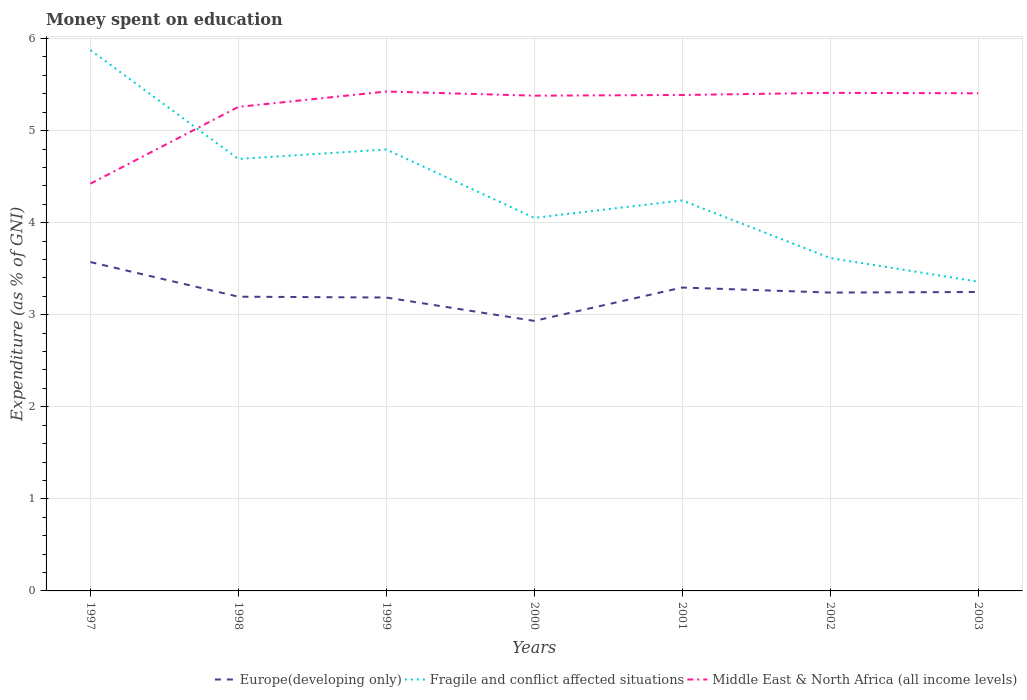Is the number of lines equal to the number of legend labels?
Give a very brief answer. Yes. Across all years, what is the maximum amount of money spent on education in Fragile and conflict affected situations?
Give a very brief answer. 3.36. What is the total amount of money spent on education in Middle East & North Africa (all income levels) in the graph?
Provide a short and direct response. -0.01. What is the difference between the highest and the second highest amount of money spent on education in Fragile and conflict affected situations?
Your answer should be compact. 2.52. How many years are there in the graph?
Provide a short and direct response. 7. Are the values on the major ticks of Y-axis written in scientific E-notation?
Make the answer very short. No. How many legend labels are there?
Ensure brevity in your answer.  3. What is the title of the graph?
Your answer should be very brief. Money spent on education. Does "Upper middle income" appear as one of the legend labels in the graph?
Make the answer very short. No. What is the label or title of the Y-axis?
Make the answer very short. Expenditure (as % of GNI). What is the Expenditure (as % of GNI) in Europe(developing only) in 1997?
Make the answer very short. 3.57. What is the Expenditure (as % of GNI) in Fragile and conflict affected situations in 1997?
Provide a succinct answer. 5.87. What is the Expenditure (as % of GNI) in Middle East & North Africa (all income levels) in 1997?
Give a very brief answer. 4.42. What is the Expenditure (as % of GNI) of Europe(developing only) in 1998?
Make the answer very short. 3.2. What is the Expenditure (as % of GNI) in Fragile and conflict affected situations in 1998?
Ensure brevity in your answer.  4.69. What is the Expenditure (as % of GNI) in Middle East & North Africa (all income levels) in 1998?
Make the answer very short. 5.26. What is the Expenditure (as % of GNI) in Europe(developing only) in 1999?
Your response must be concise. 3.19. What is the Expenditure (as % of GNI) in Fragile and conflict affected situations in 1999?
Your response must be concise. 4.79. What is the Expenditure (as % of GNI) of Middle East & North Africa (all income levels) in 1999?
Your response must be concise. 5.42. What is the Expenditure (as % of GNI) of Europe(developing only) in 2000?
Provide a succinct answer. 2.93. What is the Expenditure (as % of GNI) of Fragile and conflict affected situations in 2000?
Make the answer very short. 4.05. What is the Expenditure (as % of GNI) in Middle East & North Africa (all income levels) in 2000?
Your response must be concise. 5.38. What is the Expenditure (as % of GNI) of Europe(developing only) in 2001?
Offer a terse response. 3.3. What is the Expenditure (as % of GNI) of Fragile and conflict affected situations in 2001?
Provide a short and direct response. 4.24. What is the Expenditure (as % of GNI) of Middle East & North Africa (all income levels) in 2001?
Your answer should be very brief. 5.39. What is the Expenditure (as % of GNI) in Europe(developing only) in 2002?
Provide a short and direct response. 3.24. What is the Expenditure (as % of GNI) of Fragile and conflict affected situations in 2002?
Keep it short and to the point. 3.62. What is the Expenditure (as % of GNI) in Middle East & North Africa (all income levels) in 2002?
Your answer should be very brief. 5.41. What is the Expenditure (as % of GNI) of Europe(developing only) in 2003?
Your answer should be very brief. 3.25. What is the Expenditure (as % of GNI) in Fragile and conflict affected situations in 2003?
Offer a very short reply. 3.36. What is the Expenditure (as % of GNI) in Middle East & North Africa (all income levels) in 2003?
Make the answer very short. 5.41. Across all years, what is the maximum Expenditure (as % of GNI) in Europe(developing only)?
Provide a short and direct response. 3.57. Across all years, what is the maximum Expenditure (as % of GNI) in Fragile and conflict affected situations?
Make the answer very short. 5.87. Across all years, what is the maximum Expenditure (as % of GNI) in Middle East & North Africa (all income levels)?
Give a very brief answer. 5.42. Across all years, what is the minimum Expenditure (as % of GNI) of Europe(developing only)?
Provide a short and direct response. 2.93. Across all years, what is the minimum Expenditure (as % of GNI) in Fragile and conflict affected situations?
Provide a short and direct response. 3.36. Across all years, what is the minimum Expenditure (as % of GNI) in Middle East & North Africa (all income levels)?
Offer a terse response. 4.42. What is the total Expenditure (as % of GNI) of Europe(developing only) in the graph?
Your response must be concise. 22.67. What is the total Expenditure (as % of GNI) of Fragile and conflict affected situations in the graph?
Ensure brevity in your answer.  30.63. What is the total Expenditure (as % of GNI) in Middle East & North Africa (all income levels) in the graph?
Provide a succinct answer. 36.69. What is the difference between the Expenditure (as % of GNI) in Europe(developing only) in 1997 and that in 1998?
Provide a short and direct response. 0.38. What is the difference between the Expenditure (as % of GNI) of Fragile and conflict affected situations in 1997 and that in 1998?
Your answer should be compact. 1.18. What is the difference between the Expenditure (as % of GNI) of Middle East & North Africa (all income levels) in 1997 and that in 1998?
Give a very brief answer. -0.83. What is the difference between the Expenditure (as % of GNI) of Europe(developing only) in 1997 and that in 1999?
Give a very brief answer. 0.38. What is the difference between the Expenditure (as % of GNI) in Fragile and conflict affected situations in 1997 and that in 1999?
Ensure brevity in your answer.  1.08. What is the difference between the Expenditure (as % of GNI) of Middle East & North Africa (all income levels) in 1997 and that in 1999?
Offer a very short reply. -1. What is the difference between the Expenditure (as % of GNI) of Europe(developing only) in 1997 and that in 2000?
Offer a terse response. 0.64. What is the difference between the Expenditure (as % of GNI) in Fragile and conflict affected situations in 1997 and that in 2000?
Offer a very short reply. 1.82. What is the difference between the Expenditure (as % of GNI) in Middle East & North Africa (all income levels) in 1997 and that in 2000?
Provide a succinct answer. -0.96. What is the difference between the Expenditure (as % of GNI) of Europe(developing only) in 1997 and that in 2001?
Provide a short and direct response. 0.28. What is the difference between the Expenditure (as % of GNI) in Fragile and conflict affected situations in 1997 and that in 2001?
Keep it short and to the point. 1.63. What is the difference between the Expenditure (as % of GNI) of Middle East & North Africa (all income levels) in 1997 and that in 2001?
Provide a succinct answer. -0.96. What is the difference between the Expenditure (as % of GNI) of Europe(developing only) in 1997 and that in 2002?
Give a very brief answer. 0.33. What is the difference between the Expenditure (as % of GNI) in Fragile and conflict affected situations in 1997 and that in 2002?
Your answer should be very brief. 2.26. What is the difference between the Expenditure (as % of GNI) of Middle East & North Africa (all income levels) in 1997 and that in 2002?
Give a very brief answer. -0.99. What is the difference between the Expenditure (as % of GNI) of Europe(developing only) in 1997 and that in 2003?
Make the answer very short. 0.32. What is the difference between the Expenditure (as % of GNI) of Fragile and conflict affected situations in 1997 and that in 2003?
Make the answer very short. 2.52. What is the difference between the Expenditure (as % of GNI) of Middle East & North Africa (all income levels) in 1997 and that in 2003?
Your response must be concise. -0.98. What is the difference between the Expenditure (as % of GNI) in Europe(developing only) in 1998 and that in 1999?
Provide a short and direct response. 0.01. What is the difference between the Expenditure (as % of GNI) of Fragile and conflict affected situations in 1998 and that in 1999?
Your answer should be compact. -0.1. What is the difference between the Expenditure (as % of GNI) of Middle East & North Africa (all income levels) in 1998 and that in 1999?
Offer a very short reply. -0.17. What is the difference between the Expenditure (as % of GNI) in Europe(developing only) in 1998 and that in 2000?
Your answer should be very brief. 0.26. What is the difference between the Expenditure (as % of GNI) of Fragile and conflict affected situations in 1998 and that in 2000?
Offer a very short reply. 0.64. What is the difference between the Expenditure (as % of GNI) in Middle East & North Africa (all income levels) in 1998 and that in 2000?
Your answer should be compact. -0.12. What is the difference between the Expenditure (as % of GNI) in Europe(developing only) in 1998 and that in 2001?
Offer a very short reply. -0.1. What is the difference between the Expenditure (as % of GNI) of Fragile and conflict affected situations in 1998 and that in 2001?
Keep it short and to the point. 0.45. What is the difference between the Expenditure (as % of GNI) of Middle East & North Africa (all income levels) in 1998 and that in 2001?
Provide a short and direct response. -0.13. What is the difference between the Expenditure (as % of GNI) of Europe(developing only) in 1998 and that in 2002?
Keep it short and to the point. -0.04. What is the difference between the Expenditure (as % of GNI) in Fragile and conflict affected situations in 1998 and that in 2002?
Provide a succinct answer. 1.08. What is the difference between the Expenditure (as % of GNI) of Middle East & North Africa (all income levels) in 1998 and that in 2002?
Offer a terse response. -0.15. What is the difference between the Expenditure (as % of GNI) of Europe(developing only) in 1998 and that in 2003?
Your response must be concise. -0.05. What is the difference between the Expenditure (as % of GNI) of Fragile and conflict affected situations in 1998 and that in 2003?
Provide a succinct answer. 1.33. What is the difference between the Expenditure (as % of GNI) in Middle East & North Africa (all income levels) in 1998 and that in 2003?
Provide a short and direct response. -0.15. What is the difference between the Expenditure (as % of GNI) in Europe(developing only) in 1999 and that in 2000?
Your response must be concise. 0.25. What is the difference between the Expenditure (as % of GNI) of Fragile and conflict affected situations in 1999 and that in 2000?
Provide a short and direct response. 0.74. What is the difference between the Expenditure (as % of GNI) in Middle East & North Africa (all income levels) in 1999 and that in 2000?
Make the answer very short. 0.04. What is the difference between the Expenditure (as % of GNI) of Europe(developing only) in 1999 and that in 2001?
Make the answer very short. -0.11. What is the difference between the Expenditure (as % of GNI) of Fragile and conflict affected situations in 1999 and that in 2001?
Provide a short and direct response. 0.55. What is the difference between the Expenditure (as % of GNI) in Middle East & North Africa (all income levels) in 1999 and that in 2001?
Give a very brief answer. 0.04. What is the difference between the Expenditure (as % of GNI) in Europe(developing only) in 1999 and that in 2002?
Provide a succinct answer. -0.05. What is the difference between the Expenditure (as % of GNI) in Fragile and conflict affected situations in 1999 and that in 2002?
Offer a terse response. 1.18. What is the difference between the Expenditure (as % of GNI) in Middle East & North Africa (all income levels) in 1999 and that in 2002?
Your answer should be compact. 0.01. What is the difference between the Expenditure (as % of GNI) in Europe(developing only) in 1999 and that in 2003?
Keep it short and to the point. -0.06. What is the difference between the Expenditure (as % of GNI) of Fragile and conflict affected situations in 1999 and that in 2003?
Make the answer very short. 1.44. What is the difference between the Expenditure (as % of GNI) in Middle East & North Africa (all income levels) in 1999 and that in 2003?
Offer a very short reply. 0.02. What is the difference between the Expenditure (as % of GNI) in Europe(developing only) in 2000 and that in 2001?
Provide a short and direct response. -0.36. What is the difference between the Expenditure (as % of GNI) of Fragile and conflict affected situations in 2000 and that in 2001?
Your response must be concise. -0.19. What is the difference between the Expenditure (as % of GNI) in Middle East & North Africa (all income levels) in 2000 and that in 2001?
Provide a succinct answer. -0.01. What is the difference between the Expenditure (as % of GNI) in Europe(developing only) in 2000 and that in 2002?
Provide a succinct answer. -0.31. What is the difference between the Expenditure (as % of GNI) of Fragile and conflict affected situations in 2000 and that in 2002?
Make the answer very short. 0.44. What is the difference between the Expenditure (as % of GNI) in Middle East & North Africa (all income levels) in 2000 and that in 2002?
Keep it short and to the point. -0.03. What is the difference between the Expenditure (as % of GNI) in Europe(developing only) in 2000 and that in 2003?
Provide a short and direct response. -0.31. What is the difference between the Expenditure (as % of GNI) in Fragile and conflict affected situations in 2000 and that in 2003?
Make the answer very short. 0.69. What is the difference between the Expenditure (as % of GNI) in Middle East & North Africa (all income levels) in 2000 and that in 2003?
Ensure brevity in your answer.  -0.03. What is the difference between the Expenditure (as % of GNI) of Europe(developing only) in 2001 and that in 2002?
Make the answer very short. 0.05. What is the difference between the Expenditure (as % of GNI) of Fragile and conflict affected situations in 2001 and that in 2002?
Offer a terse response. 0.63. What is the difference between the Expenditure (as % of GNI) of Middle East & North Africa (all income levels) in 2001 and that in 2002?
Ensure brevity in your answer.  -0.02. What is the difference between the Expenditure (as % of GNI) in Europe(developing only) in 2001 and that in 2003?
Your answer should be very brief. 0.05. What is the difference between the Expenditure (as % of GNI) of Fragile and conflict affected situations in 2001 and that in 2003?
Your response must be concise. 0.88. What is the difference between the Expenditure (as % of GNI) of Middle East & North Africa (all income levels) in 2001 and that in 2003?
Provide a short and direct response. -0.02. What is the difference between the Expenditure (as % of GNI) in Europe(developing only) in 2002 and that in 2003?
Give a very brief answer. -0.01. What is the difference between the Expenditure (as % of GNI) in Fragile and conflict affected situations in 2002 and that in 2003?
Give a very brief answer. 0.26. What is the difference between the Expenditure (as % of GNI) of Middle East & North Africa (all income levels) in 2002 and that in 2003?
Keep it short and to the point. 0. What is the difference between the Expenditure (as % of GNI) of Europe(developing only) in 1997 and the Expenditure (as % of GNI) of Fragile and conflict affected situations in 1998?
Your response must be concise. -1.12. What is the difference between the Expenditure (as % of GNI) in Europe(developing only) in 1997 and the Expenditure (as % of GNI) in Middle East & North Africa (all income levels) in 1998?
Provide a short and direct response. -1.69. What is the difference between the Expenditure (as % of GNI) in Fragile and conflict affected situations in 1997 and the Expenditure (as % of GNI) in Middle East & North Africa (all income levels) in 1998?
Your answer should be compact. 0.62. What is the difference between the Expenditure (as % of GNI) of Europe(developing only) in 1997 and the Expenditure (as % of GNI) of Fragile and conflict affected situations in 1999?
Ensure brevity in your answer.  -1.22. What is the difference between the Expenditure (as % of GNI) of Europe(developing only) in 1997 and the Expenditure (as % of GNI) of Middle East & North Africa (all income levels) in 1999?
Your response must be concise. -1.85. What is the difference between the Expenditure (as % of GNI) of Fragile and conflict affected situations in 1997 and the Expenditure (as % of GNI) of Middle East & North Africa (all income levels) in 1999?
Provide a succinct answer. 0.45. What is the difference between the Expenditure (as % of GNI) of Europe(developing only) in 1997 and the Expenditure (as % of GNI) of Fragile and conflict affected situations in 2000?
Your response must be concise. -0.48. What is the difference between the Expenditure (as % of GNI) in Europe(developing only) in 1997 and the Expenditure (as % of GNI) in Middle East & North Africa (all income levels) in 2000?
Make the answer very short. -1.81. What is the difference between the Expenditure (as % of GNI) of Fragile and conflict affected situations in 1997 and the Expenditure (as % of GNI) of Middle East & North Africa (all income levels) in 2000?
Offer a terse response. 0.49. What is the difference between the Expenditure (as % of GNI) of Europe(developing only) in 1997 and the Expenditure (as % of GNI) of Fragile and conflict affected situations in 2001?
Offer a terse response. -0.67. What is the difference between the Expenditure (as % of GNI) in Europe(developing only) in 1997 and the Expenditure (as % of GNI) in Middle East & North Africa (all income levels) in 2001?
Offer a very short reply. -1.82. What is the difference between the Expenditure (as % of GNI) in Fragile and conflict affected situations in 1997 and the Expenditure (as % of GNI) in Middle East & North Africa (all income levels) in 2001?
Offer a very short reply. 0.49. What is the difference between the Expenditure (as % of GNI) of Europe(developing only) in 1997 and the Expenditure (as % of GNI) of Fragile and conflict affected situations in 2002?
Ensure brevity in your answer.  -0.04. What is the difference between the Expenditure (as % of GNI) in Europe(developing only) in 1997 and the Expenditure (as % of GNI) in Middle East & North Africa (all income levels) in 2002?
Your answer should be very brief. -1.84. What is the difference between the Expenditure (as % of GNI) in Fragile and conflict affected situations in 1997 and the Expenditure (as % of GNI) in Middle East & North Africa (all income levels) in 2002?
Provide a succinct answer. 0.46. What is the difference between the Expenditure (as % of GNI) of Europe(developing only) in 1997 and the Expenditure (as % of GNI) of Fragile and conflict affected situations in 2003?
Give a very brief answer. 0.21. What is the difference between the Expenditure (as % of GNI) of Europe(developing only) in 1997 and the Expenditure (as % of GNI) of Middle East & North Africa (all income levels) in 2003?
Your answer should be compact. -1.83. What is the difference between the Expenditure (as % of GNI) in Fragile and conflict affected situations in 1997 and the Expenditure (as % of GNI) in Middle East & North Africa (all income levels) in 2003?
Your answer should be compact. 0.47. What is the difference between the Expenditure (as % of GNI) in Europe(developing only) in 1998 and the Expenditure (as % of GNI) in Fragile and conflict affected situations in 1999?
Your answer should be compact. -1.6. What is the difference between the Expenditure (as % of GNI) of Europe(developing only) in 1998 and the Expenditure (as % of GNI) of Middle East & North Africa (all income levels) in 1999?
Offer a terse response. -2.23. What is the difference between the Expenditure (as % of GNI) of Fragile and conflict affected situations in 1998 and the Expenditure (as % of GNI) of Middle East & North Africa (all income levels) in 1999?
Your response must be concise. -0.73. What is the difference between the Expenditure (as % of GNI) in Europe(developing only) in 1998 and the Expenditure (as % of GNI) in Fragile and conflict affected situations in 2000?
Provide a short and direct response. -0.86. What is the difference between the Expenditure (as % of GNI) in Europe(developing only) in 1998 and the Expenditure (as % of GNI) in Middle East & North Africa (all income levels) in 2000?
Offer a terse response. -2.18. What is the difference between the Expenditure (as % of GNI) in Fragile and conflict affected situations in 1998 and the Expenditure (as % of GNI) in Middle East & North Africa (all income levels) in 2000?
Keep it short and to the point. -0.69. What is the difference between the Expenditure (as % of GNI) of Europe(developing only) in 1998 and the Expenditure (as % of GNI) of Fragile and conflict affected situations in 2001?
Your answer should be very brief. -1.05. What is the difference between the Expenditure (as % of GNI) of Europe(developing only) in 1998 and the Expenditure (as % of GNI) of Middle East & North Africa (all income levels) in 2001?
Your answer should be compact. -2.19. What is the difference between the Expenditure (as % of GNI) in Fragile and conflict affected situations in 1998 and the Expenditure (as % of GNI) in Middle East & North Africa (all income levels) in 2001?
Your answer should be compact. -0.7. What is the difference between the Expenditure (as % of GNI) in Europe(developing only) in 1998 and the Expenditure (as % of GNI) in Fragile and conflict affected situations in 2002?
Your answer should be compact. -0.42. What is the difference between the Expenditure (as % of GNI) in Europe(developing only) in 1998 and the Expenditure (as % of GNI) in Middle East & North Africa (all income levels) in 2002?
Your answer should be very brief. -2.21. What is the difference between the Expenditure (as % of GNI) in Fragile and conflict affected situations in 1998 and the Expenditure (as % of GNI) in Middle East & North Africa (all income levels) in 2002?
Offer a very short reply. -0.72. What is the difference between the Expenditure (as % of GNI) in Europe(developing only) in 1998 and the Expenditure (as % of GNI) in Fragile and conflict affected situations in 2003?
Offer a very short reply. -0.16. What is the difference between the Expenditure (as % of GNI) of Europe(developing only) in 1998 and the Expenditure (as % of GNI) of Middle East & North Africa (all income levels) in 2003?
Give a very brief answer. -2.21. What is the difference between the Expenditure (as % of GNI) of Fragile and conflict affected situations in 1998 and the Expenditure (as % of GNI) of Middle East & North Africa (all income levels) in 2003?
Offer a terse response. -0.71. What is the difference between the Expenditure (as % of GNI) in Europe(developing only) in 1999 and the Expenditure (as % of GNI) in Fragile and conflict affected situations in 2000?
Provide a short and direct response. -0.87. What is the difference between the Expenditure (as % of GNI) of Europe(developing only) in 1999 and the Expenditure (as % of GNI) of Middle East & North Africa (all income levels) in 2000?
Your answer should be very brief. -2.19. What is the difference between the Expenditure (as % of GNI) in Fragile and conflict affected situations in 1999 and the Expenditure (as % of GNI) in Middle East & North Africa (all income levels) in 2000?
Make the answer very short. -0.58. What is the difference between the Expenditure (as % of GNI) in Europe(developing only) in 1999 and the Expenditure (as % of GNI) in Fragile and conflict affected situations in 2001?
Give a very brief answer. -1.05. What is the difference between the Expenditure (as % of GNI) of Fragile and conflict affected situations in 1999 and the Expenditure (as % of GNI) of Middle East & North Africa (all income levels) in 2001?
Ensure brevity in your answer.  -0.59. What is the difference between the Expenditure (as % of GNI) of Europe(developing only) in 1999 and the Expenditure (as % of GNI) of Fragile and conflict affected situations in 2002?
Your answer should be very brief. -0.43. What is the difference between the Expenditure (as % of GNI) in Europe(developing only) in 1999 and the Expenditure (as % of GNI) in Middle East & North Africa (all income levels) in 2002?
Make the answer very short. -2.22. What is the difference between the Expenditure (as % of GNI) of Fragile and conflict affected situations in 1999 and the Expenditure (as % of GNI) of Middle East & North Africa (all income levels) in 2002?
Keep it short and to the point. -0.62. What is the difference between the Expenditure (as % of GNI) in Europe(developing only) in 1999 and the Expenditure (as % of GNI) in Fragile and conflict affected situations in 2003?
Your response must be concise. -0.17. What is the difference between the Expenditure (as % of GNI) in Europe(developing only) in 1999 and the Expenditure (as % of GNI) in Middle East & North Africa (all income levels) in 2003?
Make the answer very short. -2.22. What is the difference between the Expenditure (as % of GNI) of Fragile and conflict affected situations in 1999 and the Expenditure (as % of GNI) of Middle East & North Africa (all income levels) in 2003?
Offer a terse response. -0.61. What is the difference between the Expenditure (as % of GNI) in Europe(developing only) in 2000 and the Expenditure (as % of GNI) in Fragile and conflict affected situations in 2001?
Provide a short and direct response. -1.31. What is the difference between the Expenditure (as % of GNI) in Europe(developing only) in 2000 and the Expenditure (as % of GNI) in Middle East & North Africa (all income levels) in 2001?
Provide a succinct answer. -2.45. What is the difference between the Expenditure (as % of GNI) of Fragile and conflict affected situations in 2000 and the Expenditure (as % of GNI) of Middle East & North Africa (all income levels) in 2001?
Keep it short and to the point. -1.33. What is the difference between the Expenditure (as % of GNI) of Europe(developing only) in 2000 and the Expenditure (as % of GNI) of Fragile and conflict affected situations in 2002?
Give a very brief answer. -0.68. What is the difference between the Expenditure (as % of GNI) of Europe(developing only) in 2000 and the Expenditure (as % of GNI) of Middle East & North Africa (all income levels) in 2002?
Give a very brief answer. -2.48. What is the difference between the Expenditure (as % of GNI) in Fragile and conflict affected situations in 2000 and the Expenditure (as % of GNI) in Middle East & North Africa (all income levels) in 2002?
Make the answer very short. -1.36. What is the difference between the Expenditure (as % of GNI) of Europe(developing only) in 2000 and the Expenditure (as % of GNI) of Fragile and conflict affected situations in 2003?
Provide a short and direct response. -0.43. What is the difference between the Expenditure (as % of GNI) of Europe(developing only) in 2000 and the Expenditure (as % of GNI) of Middle East & North Africa (all income levels) in 2003?
Your answer should be very brief. -2.47. What is the difference between the Expenditure (as % of GNI) of Fragile and conflict affected situations in 2000 and the Expenditure (as % of GNI) of Middle East & North Africa (all income levels) in 2003?
Make the answer very short. -1.35. What is the difference between the Expenditure (as % of GNI) in Europe(developing only) in 2001 and the Expenditure (as % of GNI) in Fragile and conflict affected situations in 2002?
Keep it short and to the point. -0.32. What is the difference between the Expenditure (as % of GNI) of Europe(developing only) in 2001 and the Expenditure (as % of GNI) of Middle East & North Africa (all income levels) in 2002?
Give a very brief answer. -2.11. What is the difference between the Expenditure (as % of GNI) in Fragile and conflict affected situations in 2001 and the Expenditure (as % of GNI) in Middle East & North Africa (all income levels) in 2002?
Provide a succinct answer. -1.17. What is the difference between the Expenditure (as % of GNI) in Europe(developing only) in 2001 and the Expenditure (as % of GNI) in Fragile and conflict affected situations in 2003?
Give a very brief answer. -0.06. What is the difference between the Expenditure (as % of GNI) of Europe(developing only) in 2001 and the Expenditure (as % of GNI) of Middle East & North Africa (all income levels) in 2003?
Provide a short and direct response. -2.11. What is the difference between the Expenditure (as % of GNI) of Fragile and conflict affected situations in 2001 and the Expenditure (as % of GNI) of Middle East & North Africa (all income levels) in 2003?
Your answer should be compact. -1.16. What is the difference between the Expenditure (as % of GNI) in Europe(developing only) in 2002 and the Expenditure (as % of GNI) in Fragile and conflict affected situations in 2003?
Make the answer very short. -0.12. What is the difference between the Expenditure (as % of GNI) in Europe(developing only) in 2002 and the Expenditure (as % of GNI) in Middle East & North Africa (all income levels) in 2003?
Ensure brevity in your answer.  -2.16. What is the difference between the Expenditure (as % of GNI) of Fragile and conflict affected situations in 2002 and the Expenditure (as % of GNI) of Middle East & North Africa (all income levels) in 2003?
Keep it short and to the point. -1.79. What is the average Expenditure (as % of GNI) in Europe(developing only) per year?
Your answer should be compact. 3.24. What is the average Expenditure (as % of GNI) in Fragile and conflict affected situations per year?
Ensure brevity in your answer.  4.38. What is the average Expenditure (as % of GNI) of Middle East & North Africa (all income levels) per year?
Offer a very short reply. 5.24. In the year 1997, what is the difference between the Expenditure (as % of GNI) in Europe(developing only) and Expenditure (as % of GNI) in Fragile and conflict affected situations?
Your answer should be compact. -2.3. In the year 1997, what is the difference between the Expenditure (as % of GNI) of Europe(developing only) and Expenditure (as % of GNI) of Middle East & North Africa (all income levels)?
Your answer should be very brief. -0.85. In the year 1997, what is the difference between the Expenditure (as % of GNI) of Fragile and conflict affected situations and Expenditure (as % of GNI) of Middle East & North Africa (all income levels)?
Provide a short and direct response. 1.45. In the year 1998, what is the difference between the Expenditure (as % of GNI) in Europe(developing only) and Expenditure (as % of GNI) in Fragile and conflict affected situations?
Make the answer very short. -1.5. In the year 1998, what is the difference between the Expenditure (as % of GNI) of Europe(developing only) and Expenditure (as % of GNI) of Middle East & North Africa (all income levels)?
Keep it short and to the point. -2.06. In the year 1998, what is the difference between the Expenditure (as % of GNI) of Fragile and conflict affected situations and Expenditure (as % of GNI) of Middle East & North Africa (all income levels)?
Make the answer very short. -0.57. In the year 1999, what is the difference between the Expenditure (as % of GNI) of Europe(developing only) and Expenditure (as % of GNI) of Fragile and conflict affected situations?
Offer a terse response. -1.61. In the year 1999, what is the difference between the Expenditure (as % of GNI) in Europe(developing only) and Expenditure (as % of GNI) in Middle East & North Africa (all income levels)?
Keep it short and to the point. -2.24. In the year 1999, what is the difference between the Expenditure (as % of GNI) of Fragile and conflict affected situations and Expenditure (as % of GNI) of Middle East & North Africa (all income levels)?
Your answer should be compact. -0.63. In the year 2000, what is the difference between the Expenditure (as % of GNI) in Europe(developing only) and Expenditure (as % of GNI) in Fragile and conflict affected situations?
Keep it short and to the point. -1.12. In the year 2000, what is the difference between the Expenditure (as % of GNI) in Europe(developing only) and Expenditure (as % of GNI) in Middle East & North Africa (all income levels)?
Offer a very short reply. -2.45. In the year 2000, what is the difference between the Expenditure (as % of GNI) in Fragile and conflict affected situations and Expenditure (as % of GNI) in Middle East & North Africa (all income levels)?
Provide a short and direct response. -1.33. In the year 2001, what is the difference between the Expenditure (as % of GNI) of Europe(developing only) and Expenditure (as % of GNI) of Fragile and conflict affected situations?
Offer a terse response. -0.95. In the year 2001, what is the difference between the Expenditure (as % of GNI) of Europe(developing only) and Expenditure (as % of GNI) of Middle East & North Africa (all income levels)?
Ensure brevity in your answer.  -2.09. In the year 2001, what is the difference between the Expenditure (as % of GNI) in Fragile and conflict affected situations and Expenditure (as % of GNI) in Middle East & North Africa (all income levels)?
Provide a succinct answer. -1.15. In the year 2002, what is the difference between the Expenditure (as % of GNI) of Europe(developing only) and Expenditure (as % of GNI) of Fragile and conflict affected situations?
Give a very brief answer. -0.38. In the year 2002, what is the difference between the Expenditure (as % of GNI) in Europe(developing only) and Expenditure (as % of GNI) in Middle East & North Africa (all income levels)?
Offer a terse response. -2.17. In the year 2002, what is the difference between the Expenditure (as % of GNI) of Fragile and conflict affected situations and Expenditure (as % of GNI) of Middle East & North Africa (all income levels)?
Provide a short and direct response. -1.79. In the year 2003, what is the difference between the Expenditure (as % of GNI) in Europe(developing only) and Expenditure (as % of GNI) in Fragile and conflict affected situations?
Your response must be concise. -0.11. In the year 2003, what is the difference between the Expenditure (as % of GNI) in Europe(developing only) and Expenditure (as % of GNI) in Middle East & North Africa (all income levels)?
Keep it short and to the point. -2.16. In the year 2003, what is the difference between the Expenditure (as % of GNI) in Fragile and conflict affected situations and Expenditure (as % of GNI) in Middle East & North Africa (all income levels)?
Give a very brief answer. -2.05. What is the ratio of the Expenditure (as % of GNI) in Europe(developing only) in 1997 to that in 1998?
Make the answer very short. 1.12. What is the ratio of the Expenditure (as % of GNI) of Fragile and conflict affected situations in 1997 to that in 1998?
Provide a succinct answer. 1.25. What is the ratio of the Expenditure (as % of GNI) of Middle East & North Africa (all income levels) in 1997 to that in 1998?
Your answer should be compact. 0.84. What is the ratio of the Expenditure (as % of GNI) of Europe(developing only) in 1997 to that in 1999?
Offer a very short reply. 1.12. What is the ratio of the Expenditure (as % of GNI) of Fragile and conflict affected situations in 1997 to that in 1999?
Ensure brevity in your answer.  1.23. What is the ratio of the Expenditure (as % of GNI) in Middle East & North Africa (all income levels) in 1997 to that in 1999?
Make the answer very short. 0.82. What is the ratio of the Expenditure (as % of GNI) in Europe(developing only) in 1997 to that in 2000?
Offer a terse response. 1.22. What is the ratio of the Expenditure (as % of GNI) in Fragile and conflict affected situations in 1997 to that in 2000?
Give a very brief answer. 1.45. What is the ratio of the Expenditure (as % of GNI) of Middle East & North Africa (all income levels) in 1997 to that in 2000?
Provide a short and direct response. 0.82. What is the ratio of the Expenditure (as % of GNI) of Europe(developing only) in 1997 to that in 2001?
Keep it short and to the point. 1.08. What is the ratio of the Expenditure (as % of GNI) of Fragile and conflict affected situations in 1997 to that in 2001?
Your answer should be compact. 1.38. What is the ratio of the Expenditure (as % of GNI) in Middle East & North Africa (all income levels) in 1997 to that in 2001?
Make the answer very short. 0.82. What is the ratio of the Expenditure (as % of GNI) of Europe(developing only) in 1997 to that in 2002?
Ensure brevity in your answer.  1.1. What is the ratio of the Expenditure (as % of GNI) of Fragile and conflict affected situations in 1997 to that in 2002?
Offer a terse response. 1.62. What is the ratio of the Expenditure (as % of GNI) of Middle East & North Africa (all income levels) in 1997 to that in 2002?
Ensure brevity in your answer.  0.82. What is the ratio of the Expenditure (as % of GNI) of Fragile and conflict affected situations in 1997 to that in 2003?
Your answer should be compact. 1.75. What is the ratio of the Expenditure (as % of GNI) of Middle East & North Africa (all income levels) in 1997 to that in 2003?
Make the answer very short. 0.82. What is the ratio of the Expenditure (as % of GNI) in Fragile and conflict affected situations in 1998 to that in 1999?
Give a very brief answer. 0.98. What is the ratio of the Expenditure (as % of GNI) of Middle East & North Africa (all income levels) in 1998 to that in 1999?
Provide a short and direct response. 0.97. What is the ratio of the Expenditure (as % of GNI) in Europe(developing only) in 1998 to that in 2000?
Offer a terse response. 1.09. What is the ratio of the Expenditure (as % of GNI) in Fragile and conflict affected situations in 1998 to that in 2000?
Make the answer very short. 1.16. What is the ratio of the Expenditure (as % of GNI) of Middle East & North Africa (all income levels) in 1998 to that in 2000?
Offer a very short reply. 0.98. What is the ratio of the Expenditure (as % of GNI) in Europe(developing only) in 1998 to that in 2001?
Your answer should be compact. 0.97. What is the ratio of the Expenditure (as % of GNI) of Fragile and conflict affected situations in 1998 to that in 2001?
Your answer should be compact. 1.11. What is the ratio of the Expenditure (as % of GNI) of Middle East & North Africa (all income levels) in 1998 to that in 2001?
Offer a terse response. 0.98. What is the ratio of the Expenditure (as % of GNI) in Europe(developing only) in 1998 to that in 2002?
Make the answer very short. 0.99. What is the ratio of the Expenditure (as % of GNI) of Fragile and conflict affected situations in 1998 to that in 2002?
Offer a very short reply. 1.3. What is the ratio of the Expenditure (as % of GNI) of Middle East & North Africa (all income levels) in 1998 to that in 2002?
Provide a succinct answer. 0.97. What is the ratio of the Expenditure (as % of GNI) of Europe(developing only) in 1998 to that in 2003?
Provide a succinct answer. 0.98. What is the ratio of the Expenditure (as % of GNI) of Fragile and conflict affected situations in 1998 to that in 2003?
Ensure brevity in your answer.  1.4. What is the ratio of the Expenditure (as % of GNI) of Middle East & North Africa (all income levels) in 1998 to that in 2003?
Your answer should be compact. 0.97. What is the ratio of the Expenditure (as % of GNI) of Europe(developing only) in 1999 to that in 2000?
Your response must be concise. 1.09. What is the ratio of the Expenditure (as % of GNI) in Fragile and conflict affected situations in 1999 to that in 2000?
Offer a very short reply. 1.18. What is the ratio of the Expenditure (as % of GNI) of Middle East & North Africa (all income levels) in 1999 to that in 2000?
Your answer should be very brief. 1.01. What is the ratio of the Expenditure (as % of GNI) in Europe(developing only) in 1999 to that in 2001?
Your response must be concise. 0.97. What is the ratio of the Expenditure (as % of GNI) of Fragile and conflict affected situations in 1999 to that in 2001?
Ensure brevity in your answer.  1.13. What is the ratio of the Expenditure (as % of GNI) in Europe(developing only) in 1999 to that in 2002?
Your answer should be compact. 0.98. What is the ratio of the Expenditure (as % of GNI) of Fragile and conflict affected situations in 1999 to that in 2002?
Offer a terse response. 1.33. What is the ratio of the Expenditure (as % of GNI) in Middle East & North Africa (all income levels) in 1999 to that in 2002?
Your response must be concise. 1. What is the ratio of the Expenditure (as % of GNI) in Europe(developing only) in 1999 to that in 2003?
Offer a terse response. 0.98. What is the ratio of the Expenditure (as % of GNI) of Fragile and conflict affected situations in 1999 to that in 2003?
Make the answer very short. 1.43. What is the ratio of the Expenditure (as % of GNI) of Europe(developing only) in 2000 to that in 2001?
Give a very brief answer. 0.89. What is the ratio of the Expenditure (as % of GNI) of Fragile and conflict affected situations in 2000 to that in 2001?
Provide a succinct answer. 0.96. What is the ratio of the Expenditure (as % of GNI) in Middle East & North Africa (all income levels) in 2000 to that in 2001?
Provide a short and direct response. 1. What is the ratio of the Expenditure (as % of GNI) in Europe(developing only) in 2000 to that in 2002?
Offer a terse response. 0.91. What is the ratio of the Expenditure (as % of GNI) of Fragile and conflict affected situations in 2000 to that in 2002?
Offer a terse response. 1.12. What is the ratio of the Expenditure (as % of GNI) in Middle East & North Africa (all income levels) in 2000 to that in 2002?
Ensure brevity in your answer.  0.99. What is the ratio of the Expenditure (as % of GNI) in Europe(developing only) in 2000 to that in 2003?
Ensure brevity in your answer.  0.9. What is the ratio of the Expenditure (as % of GNI) in Fragile and conflict affected situations in 2000 to that in 2003?
Offer a terse response. 1.21. What is the ratio of the Expenditure (as % of GNI) in Europe(developing only) in 2001 to that in 2002?
Provide a short and direct response. 1.02. What is the ratio of the Expenditure (as % of GNI) in Fragile and conflict affected situations in 2001 to that in 2002?
Give a very brief answer. 1.17. What is the ratio of the Expenditure (as % of GNI) of Europe(developing only) in 2001 to that in 2003?
Provide a short and direct response. 1.01. What is the ratio of the Expenditure (as % of GNI) in Fragile and conflict affected situations in 2001 to that in 2003?
Offer a very short reply. 1.26. What is the ratio of the Expenditure (as % of GNI) in Europe(developing only) in 2002 to that in 2003?
Keep it short and to the point. 1. What is the ratio of the Expenditure (as % of GNI) in Fragile and conflict affected situations in 2002 to that in 2003?
Your response must be concise. 1.08. What is the difference between the highest and the second highest Expenditure (as % of GNI) of Europe(developing only)?
Offer a very short reply. 0.28. What is the difference between the highest and the second highest Expenditure (as % of GNI) in Fragile and conflict affected situations?
Keep it short and to the point. 1.08. What is the difference between the highest and the second highest Expenditure (as % of GNI) in Middle East & North Africa (all income levels)?
Ensure brevity in your answer.  0.01. What is the difference between the highest and the lowest Expenditure (as % of GNI) of Europe(developing only)?
Keep it short and to the point. 0.64. What is the difference between the highest and the lowest Expenditure (as % of GNI) of Fragile and conflict affected situations?
Offer a terse response. 2.52. 